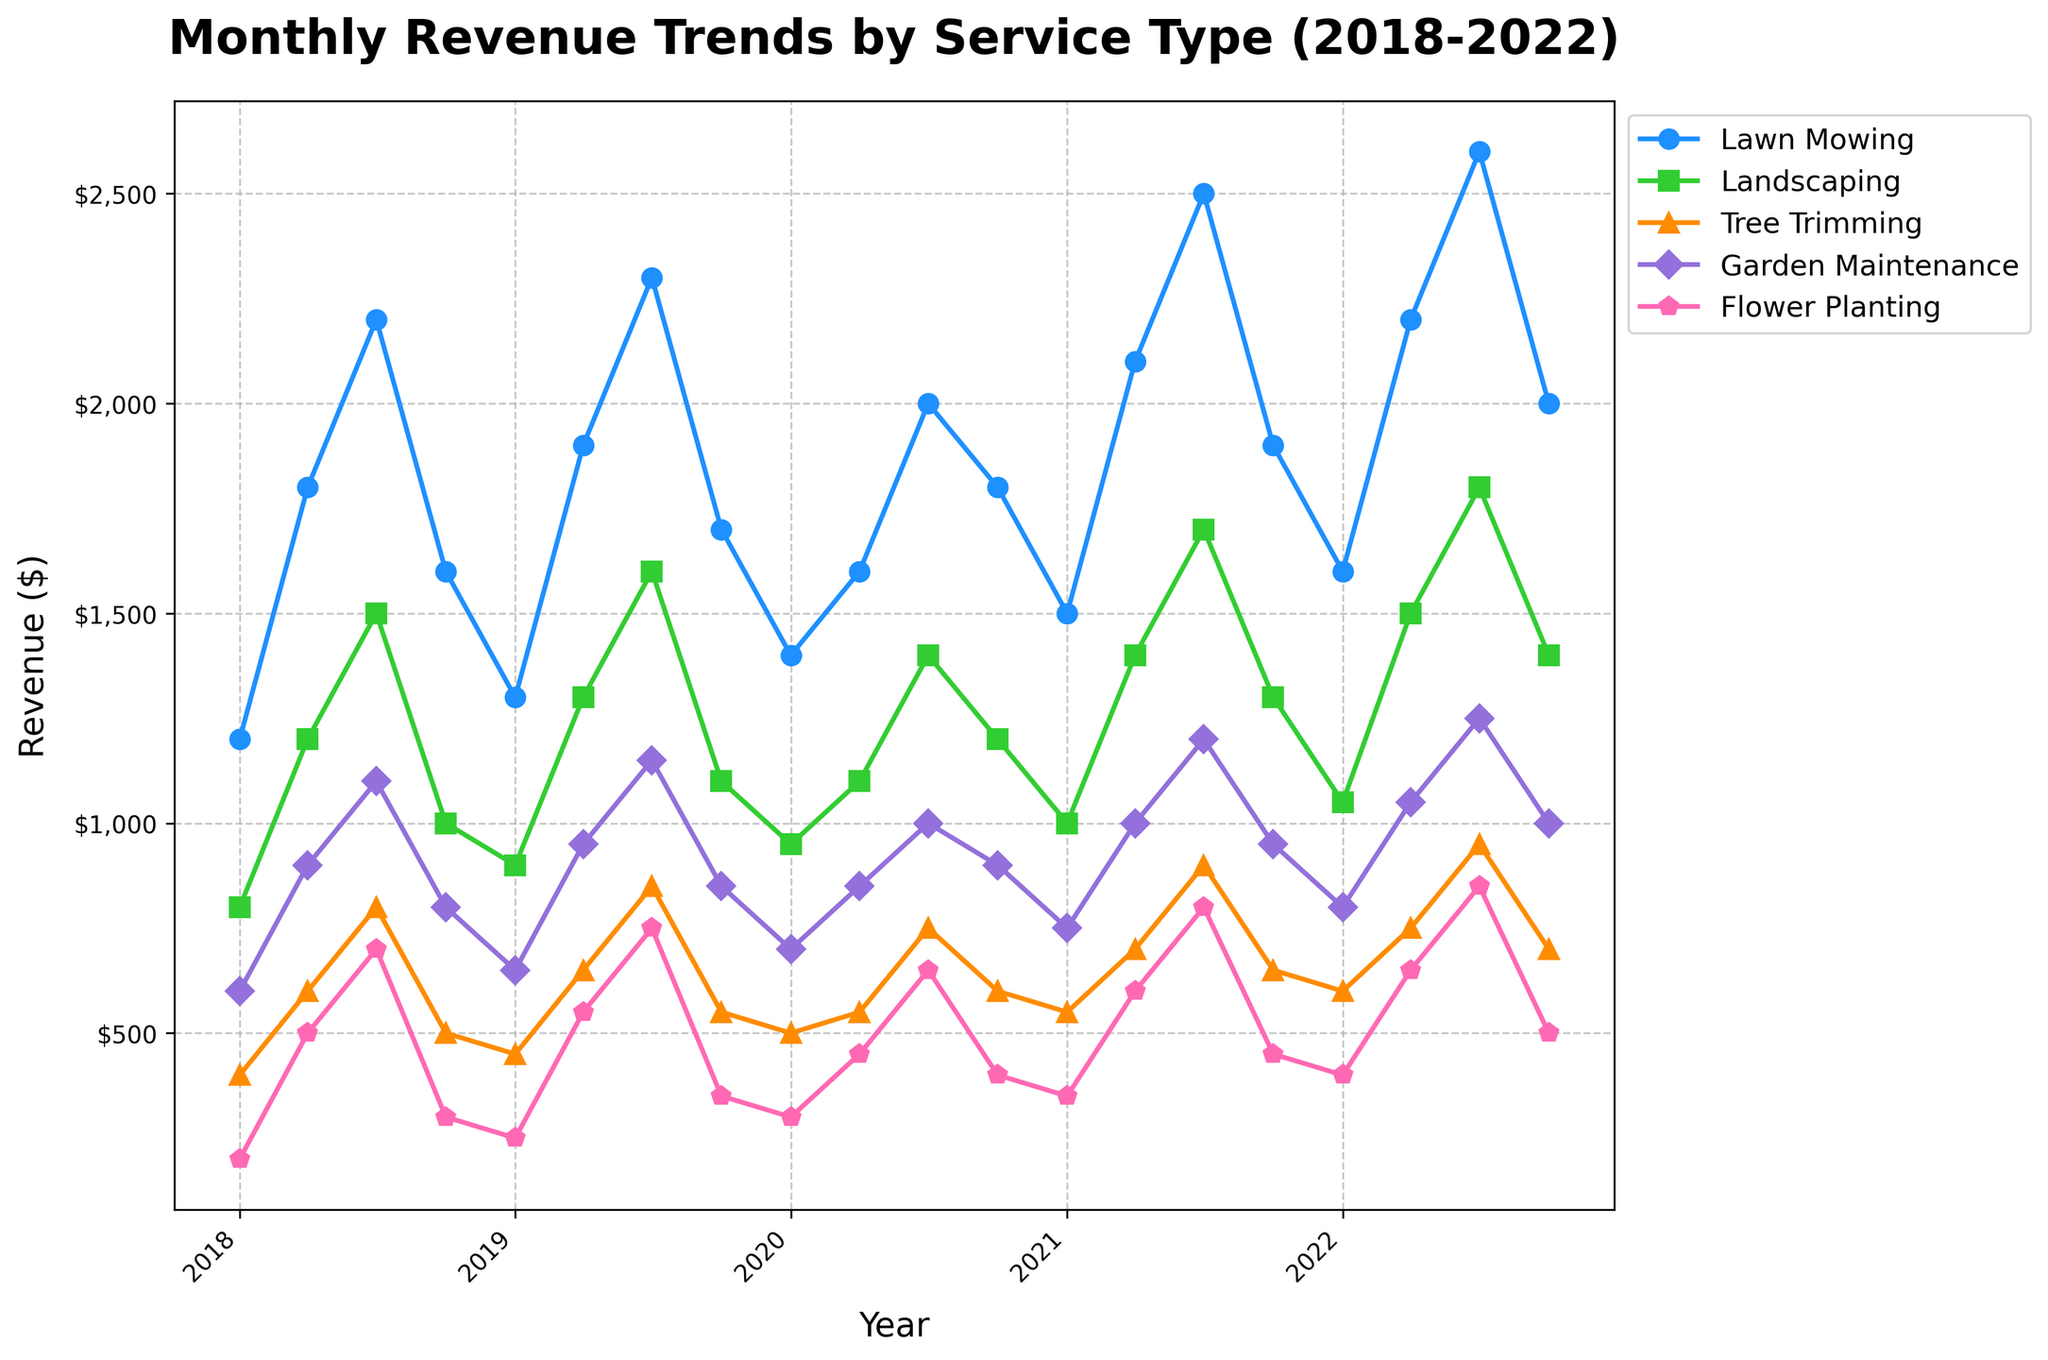What was the revenue for Lawn Mowing in January 2019? Identify the point corresponding to January 2019 on the x-axis and look at the height of the Lawn Mowing line.
Answer: $1300 Which service had the highest revenue in July 2021? Identify the points corresponding to July 2021 on the x-axis for all services and compare their heights.
Answer: Lawn Mowing How did the revenue for Flower Planting change from April 2021 to July 2021? Find the points for Flower Planting in April 2021 and July 2021 on the x-axis and compare their heights to see if it increased or decreased.
Answer: Increased Which service had the lowest revenue in October 2022? Identify the points corresponding to October 2022 for all services and find the one with the lowest height.
Answer: Flower Planting What's the average revenue for Landscaping over the entire period? Sum all the revenue values for Landscaping and divide by the number of points.
Answer: $1268.75 Compare the revenue trends for Lawn Mowing and Landscaping in 2020. Which service generally performed better? Compare the heights of lines for Lawn Mowing and Landscaping throughout the year 2020, month by month.
Answer: Lawn Mowing During which year did Lawn Mowing see the highest revenue? Find the highest point on the Lawn Mowing line and note the year on the x-axis.
Answer: 2022 By how much did Garden Maintenance revenue increase from January 2018 to July 2022? Find the revenue values for Garden Maintenance in January 2018 and July 2022, then subtract the former from the latter.
Answer: $650 Which service showed the most significant increase in revenue from January to July in any given year? For each service, compare the revenue figures between January and July within the same year across all years and identify the largest increase.
Answer: Lawn Mowing in 2018 What is the combined revenue for all services in April 2018? Sum the revenue values for all services in April 2018.
Answer: $5,000 